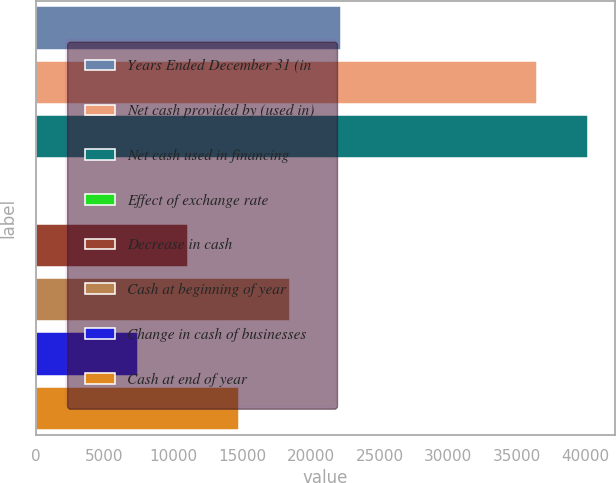Convert chart to OTSL. <chart><loc_0><loc_0><loc_500><loc_500><bar_chart><fcel>Years Ended December 31 (in<fcel>Net cash provided by (used in)<fcel>Net cash used in financing<fcel>Effect of exchange rate<fcel>Decrease in cash<fcel>Cash at beginning of year<fcel>Change in cash of businesses<fcel>Cash at end of year<nl><fcel>22167.2<fcel>36448<fcel>40137.7<fcel>29<fcel>11098.1<fcel>18477.5<fcel>7408.4<fcel>14787.8<nl></chart> 